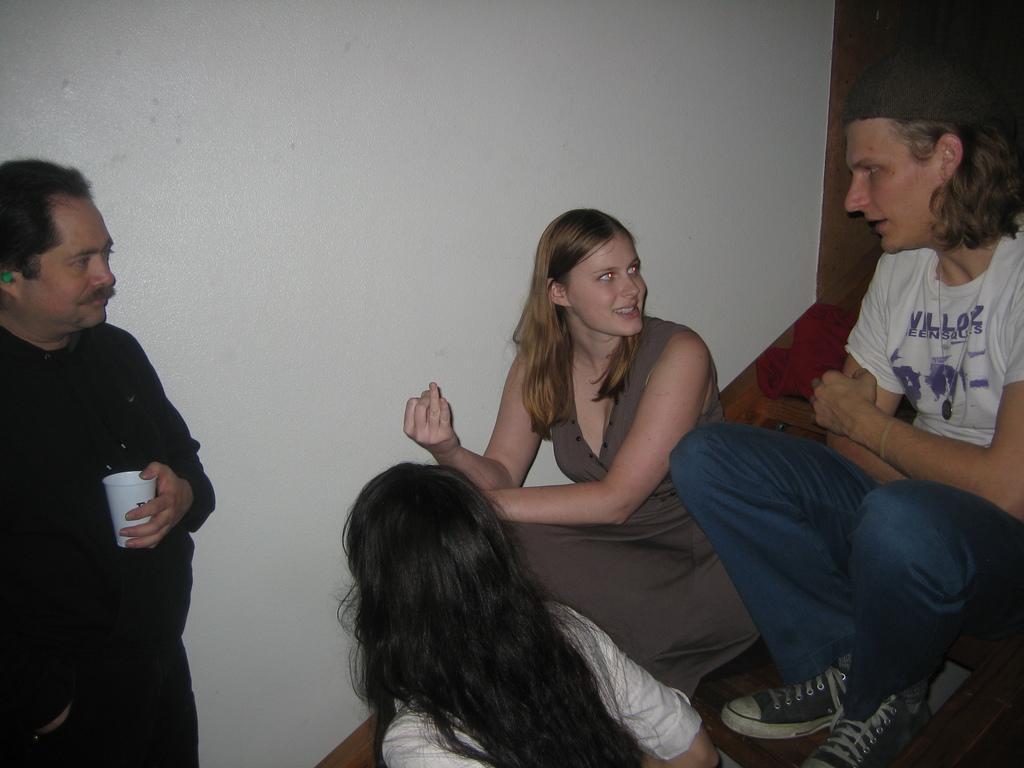Please provide a concise description of this image. In the picture I can see two persons sitting on the wooden staircase and they are having a conversation. I can see a woman at the bottom of the picture. There is a man on the left side holding a glass in his left hand. I can see the wall. 